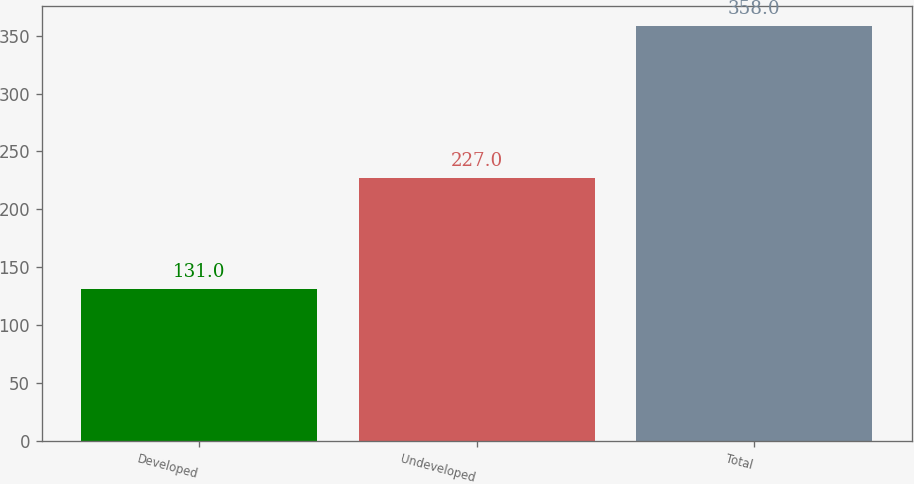Convert chart to OTSL. <chart><loc_0><loc_0><loc_500><loc_500><bar_chart><fcel>Developed<fcel>Undeveloped<fcel>Total<nl><fcel>131<fcel>227<fcel>358<nl></chart> 